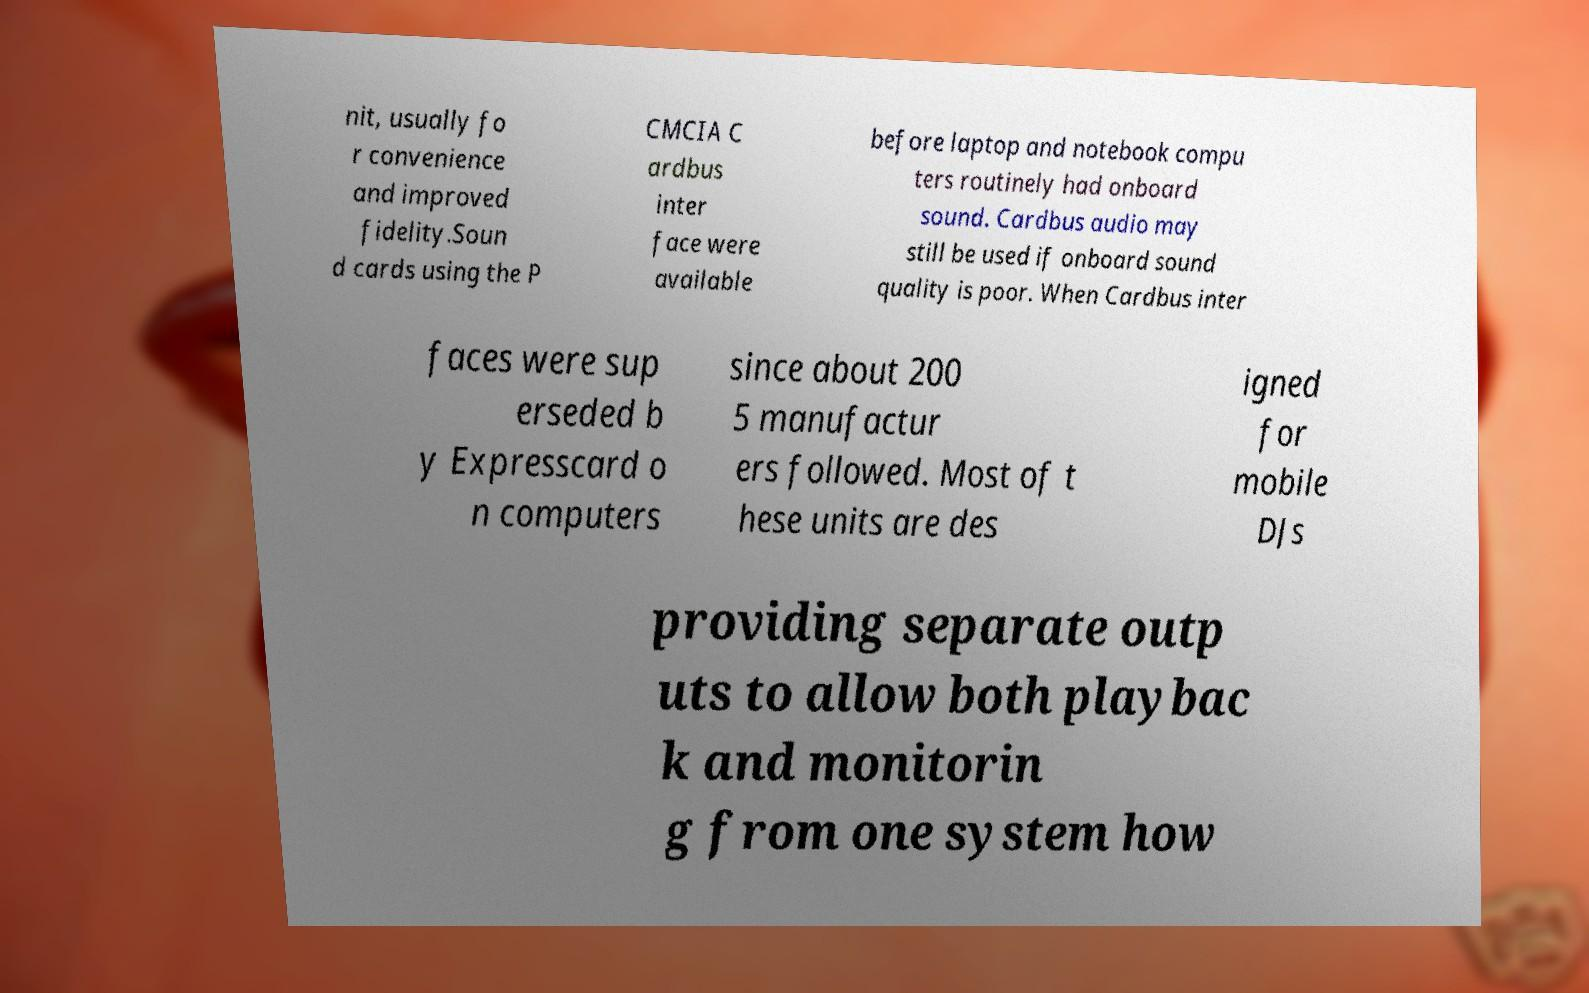I need the written content from this picture converted into text. Can you do that? nit, usually fo r convenience and improved fidelity.Soun d cards using the P CMCIA C ardbus inter face were available before laptop and notebook compu ters routinely had onboard sound. Cardbus audio may still be used if onboard sound quality is poor. When Cardbus inter faces were sup erseded b y Expresscard o n computers since about 200 5 manufactur ers followed. Most of t hese units are des igned for mobile DJs providing separate outp uts to allow both playbac k and monitorin g from one system how 